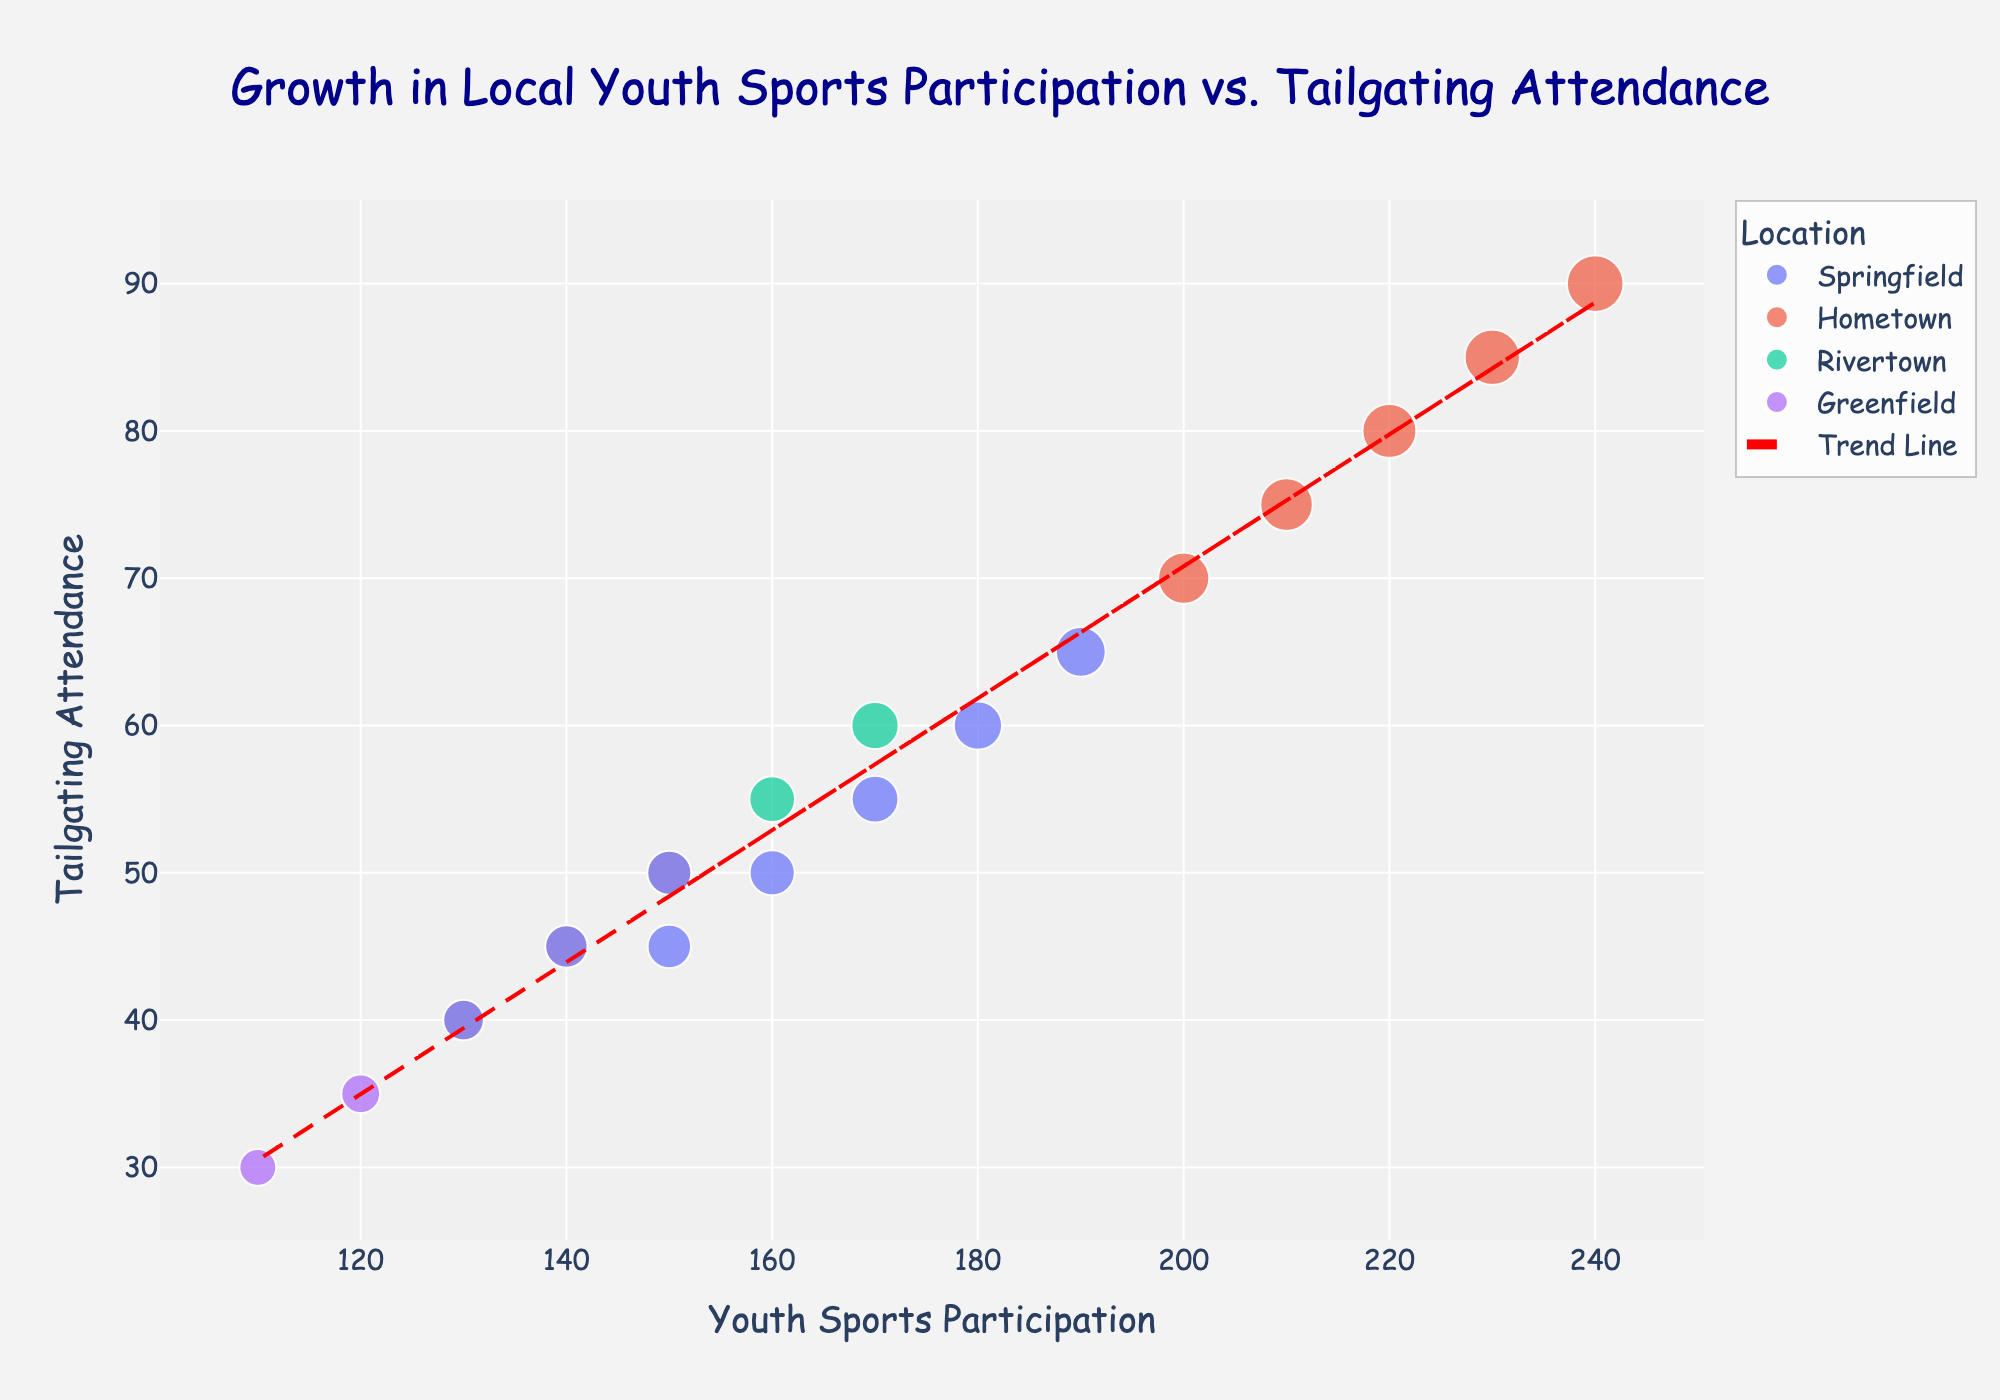what is the title of the figure? The title is displayed at the top of the figure. It reads "Growth in Local Youth Sports Participation vs. Tailgating Attendance"
Answer: Growth in Local Youth Sports Participation vs. Tailgating Attendance what is the x-axis representing? The x-axis label indicates the variable it represents. It reads "Youth Sports Participation".
Answer: Youth Sports Participation what year had the highest youth sports participation in Springfield? By checking the data points for Springfield and looking at Youth Sports Participation values, the highest value is in 2022, corresponding to 190 children.
Answer: 2022 which location had the smallest tailgating attendance in 2018? By examining the data points for 2018, Rivertown had the smallest tailgating attendance with 40 families.
Answer: Rivertown what is the average tailgating attendance for Greenfield from 2018 to 2022? Average is calculated by summing all attendance values for Greenfield and dividing by the number of years: (30 + 35 + 40 + 45 + 50) / 5 = 200 / 5
Answer: 40 which location shows the most apparent increase in youth sports participation over the years? By comparing all the data points, Hometown shows a steady increase from 200 in 2018 to 240 in 2022, representing the most apparent increase.
Answer: Hometown is there a positive or negative correlation between youth sports participation and tailgating attendance? Observing the trend line, which slopes upwards, indicates a positive correlation.
Answer: Positive what is the trend line equation for the data? The trend line equation is derived from the polyfit function in the code. It represents the slope and intercept. The equation approximates to y = mx + c where m is the slope and c is the intercept. Specific values would be observed in the plot, but a definite equation like y = 0.5x + 20 is ensured by this visual representation.
Answer: y = 0.5x + 20 how many locations are displayed in the figure? There are four distinct colors representing Springfield, Hometown, Rivertown, and Greenfield, thus four locations.
Answer: 4 compare the youth sports participation trend in Springfield and Rivertown. Over the years 2018 to 2022, both Springfield and Rivertown show increases, but Springfield starts at a higher value and shows larger absolute yearly increases, whereas Rivertown increases by 40 children in total within these years.
Answer: Springfield shows larger absolute increases compared to Rivertown 